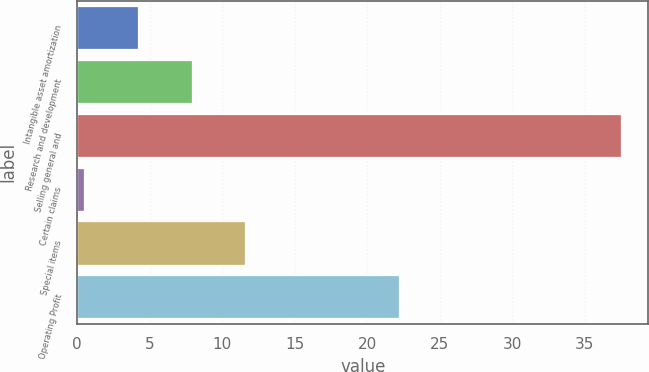Convert chart. <chart><loc_0><loc_0><loc_500><loc_500><bar_chart><fcel>Intangible asset amortization<fcel>Research and development<fcel>Selling general and<fcel>Certain claims<fcel>Special items<fcel>Operating Profit<nl><fcel>4.2<fcel>7.9<fcel>37.5<fcel>0.5<fcel>11.6<fcel>22.2<nl></chart> 